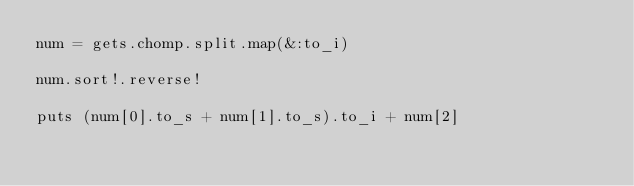Convert code to text. <code><loc_0><loc_0><loc_500><loc_500><_Ruby_>num = gets.chomp.split.map(&:to_i)

num.sort!.reverse!

puts (num[0].to_s + num[1].to_s).to_i + num[2]</code> 